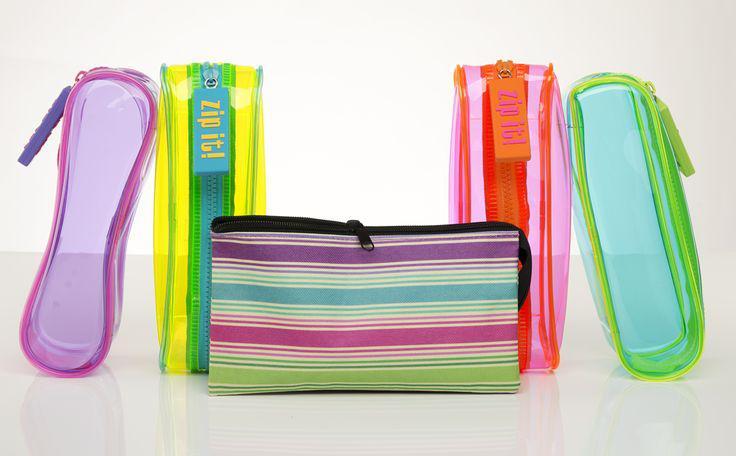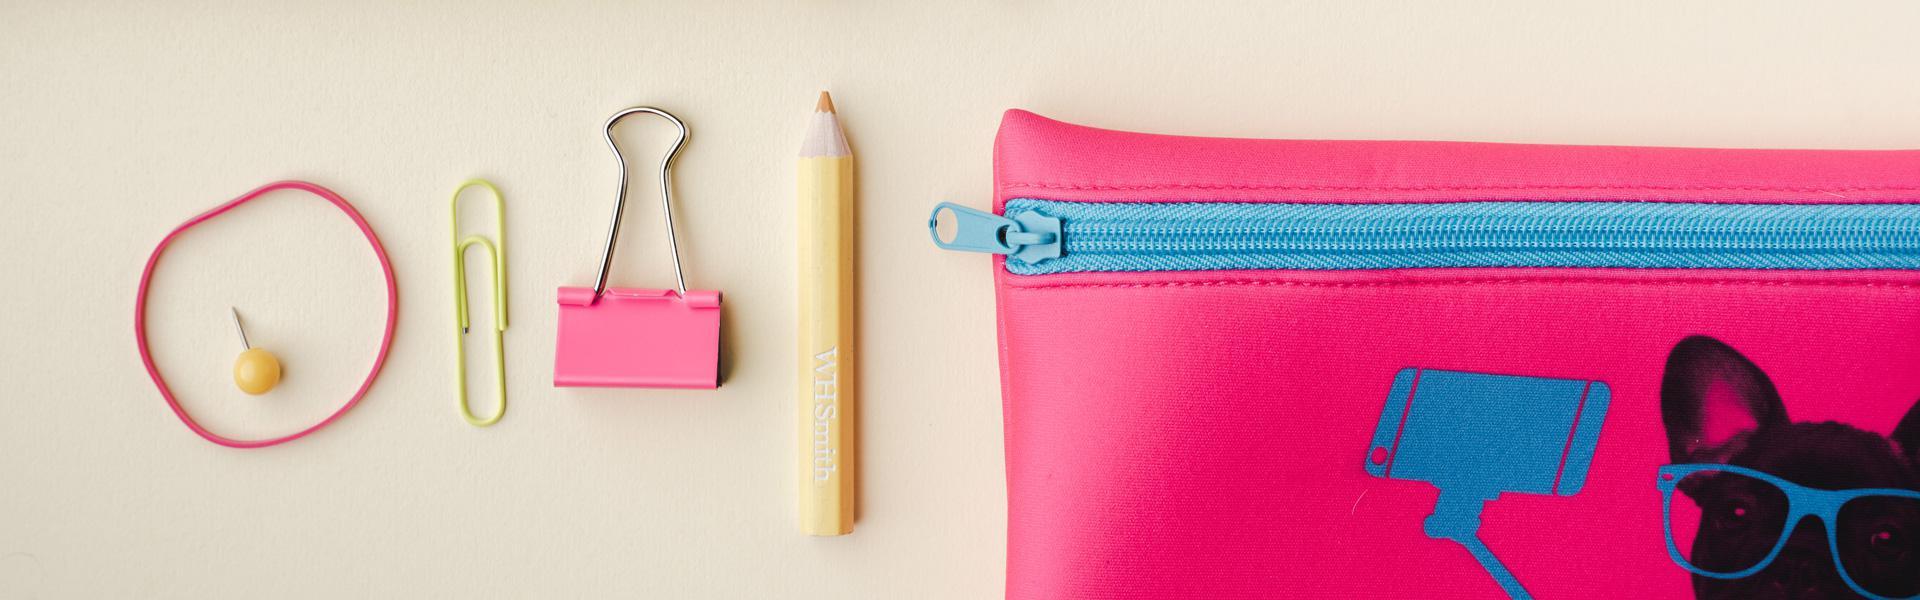The first image is the image on the left, the second image is the image on the right. Examine the images to the left and right. Is the description "There is a bag with a multi-colored polka dot pattern on it." accurate? Answer yes or no. No. 